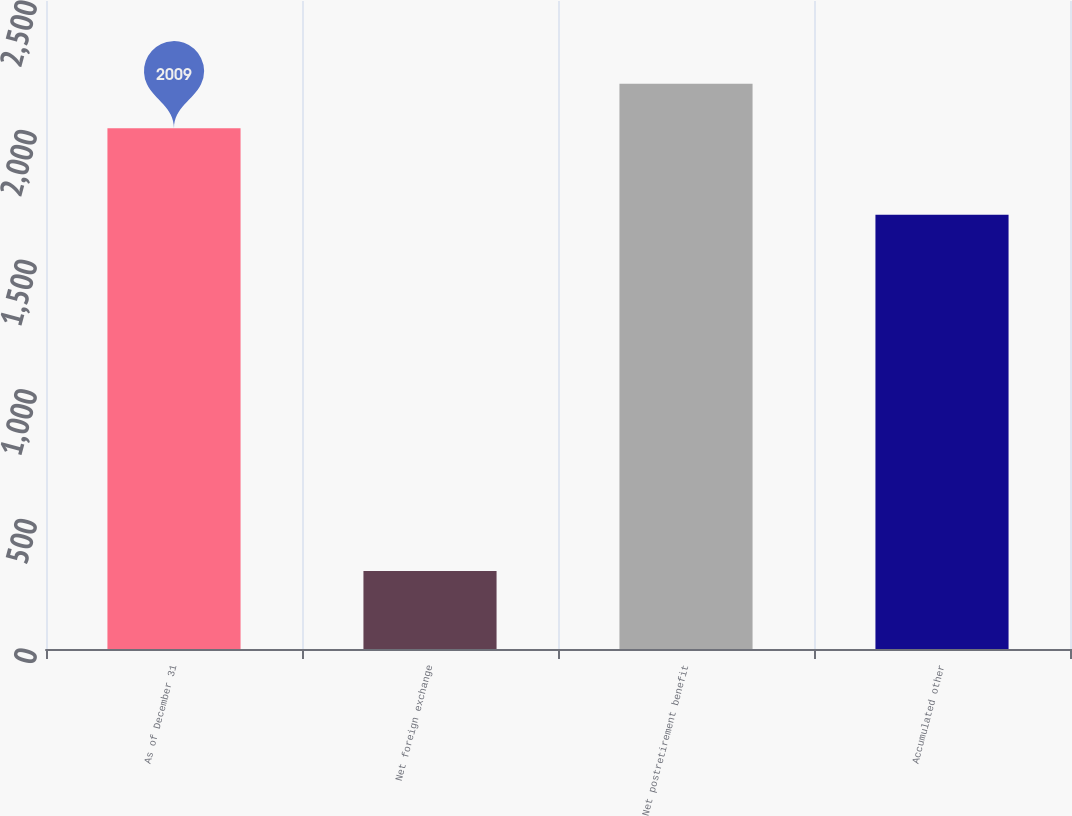Convert chart to OTSL. <chart><loc_0><loc_0><loc_500><loc_500><bar_chart><fcel>As of December 31<fcel>Net foreign exchange<fcel>Net postretirement benefit<fcel>Accumulated other<nl><fcel>2009<fcel>301<fcel>2180.9<fcel>1675<nl></chart> 